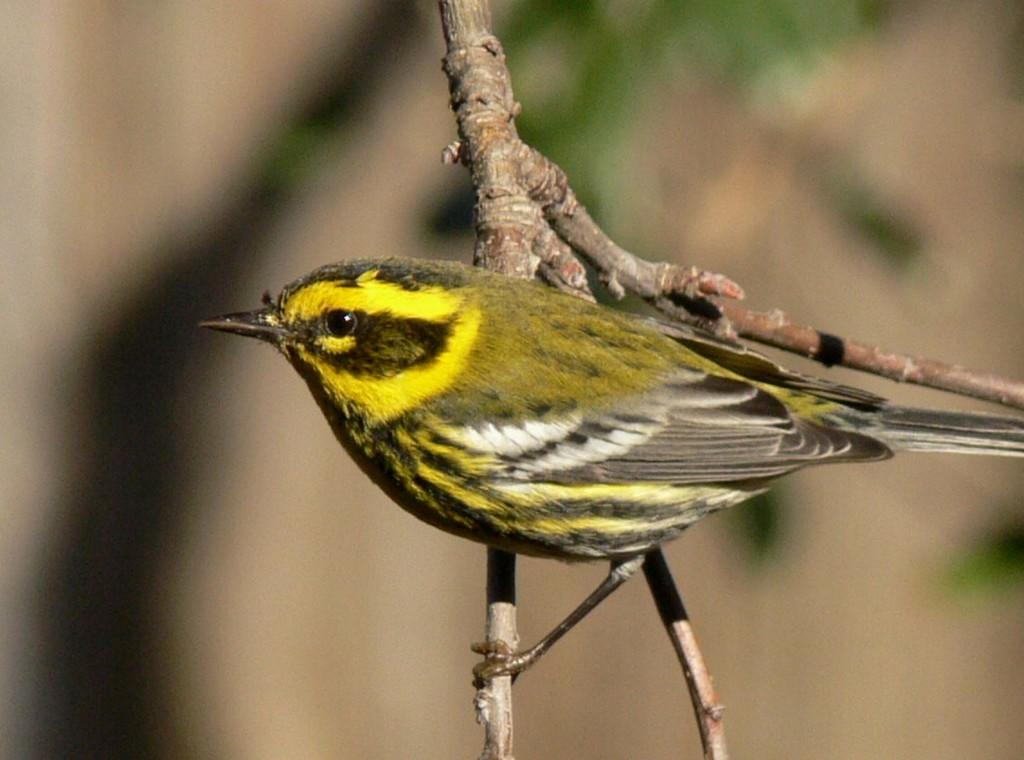What type of animal can be seen in the image? There is a bird in the image. Where is the bird located? The bird is on a branch of a tree. Can you describe the position of the bird in the image? The bird is in the middle of the image. What type of stone is the bird using to climb the tree in the image? There is no stone present in the image, and the bird is not climbing the tree. 